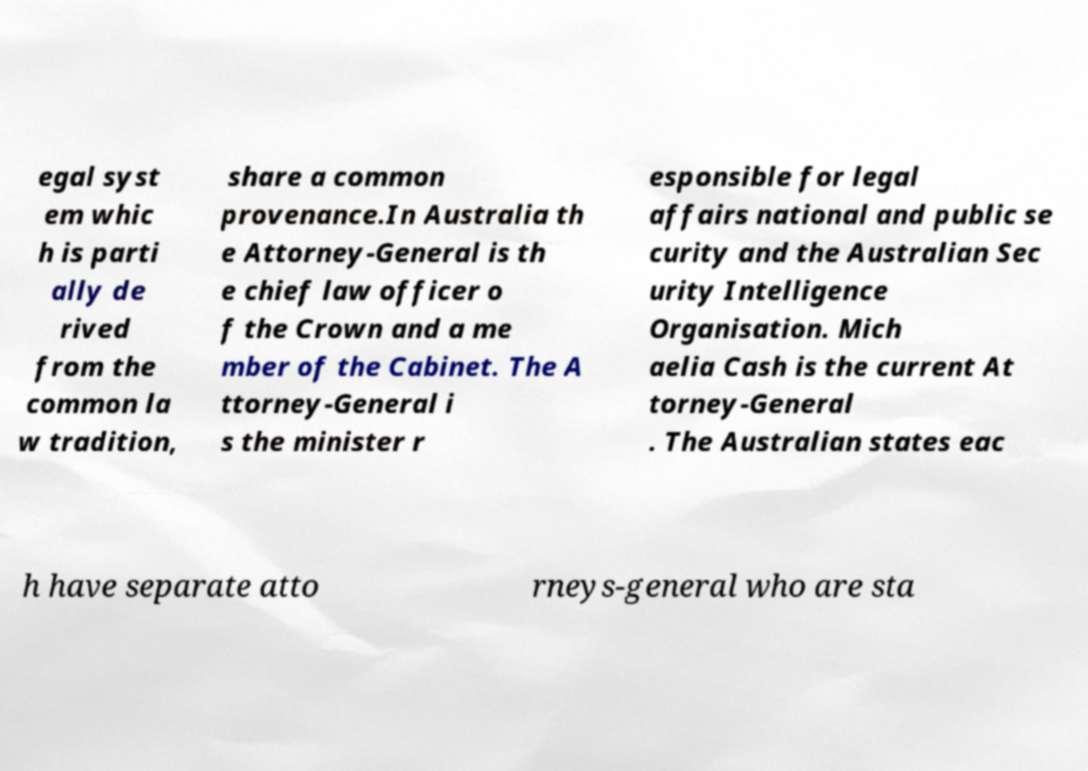For documentation purposes, I need the text within this image transcribed. Could you provide that? egal syst em whic h is parti ally de rived from the common la w tradition, share a common provenance.In Australia th e Attorney-General is th e chief law officer o f the Crown and a me mber of the Cabinet. The A ttorney-General i s the minister r esponsible for legal affairs national and public se curity and the Australian Sec urity Intelligence Organisation. Mich aelia Cash is the current At torney-General . The Australian states eac h have separate atto rneys-general who are sta 